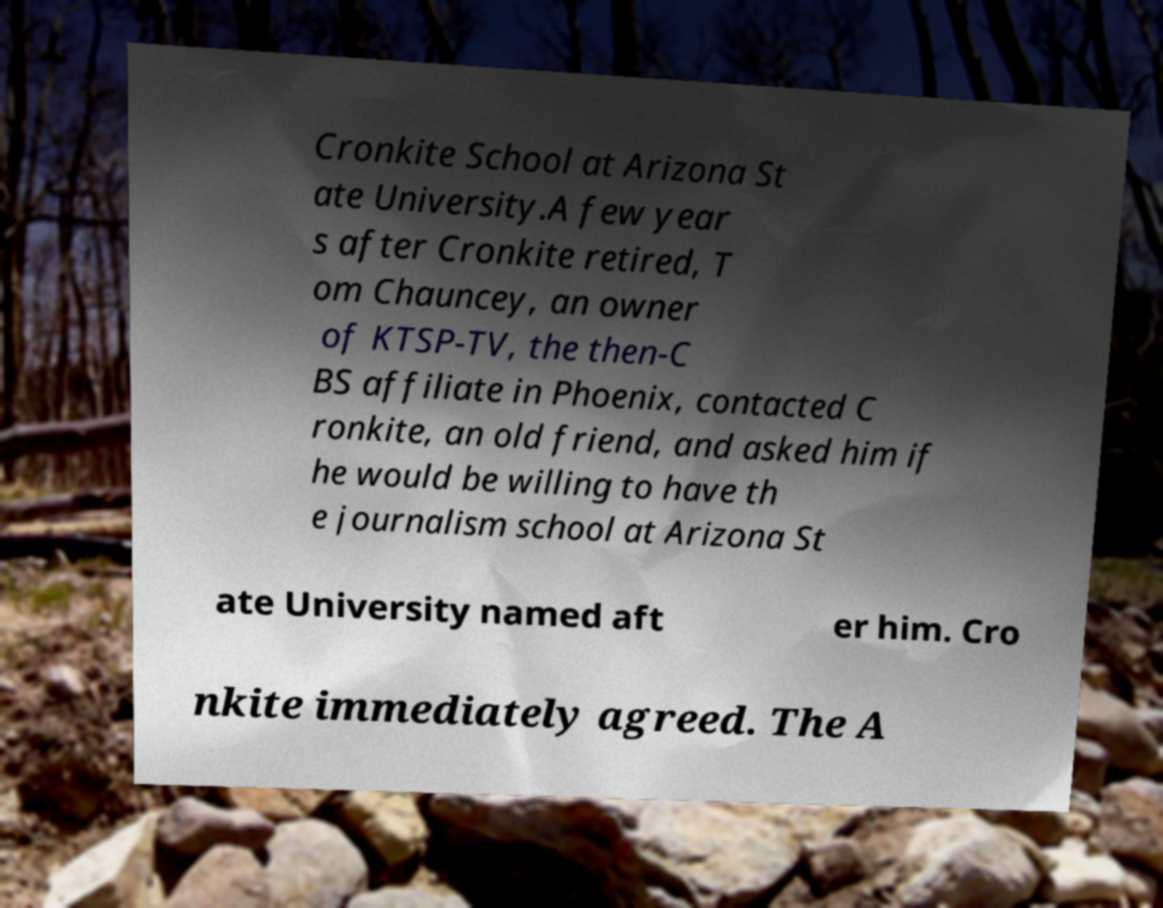Could you extract and type out the text from this image? Cronkite School at Arizona St ate University.A few year s after Cronkite retired, T om Chauncey, an owner of KTSP-TV, the then-C BS affiliate in Phoenix, contacted C ronkite, an old friend, and asked him if he would be willing to have th e journalism school at Arizona St ate University named aft er him. Cro nkite immediately agreed. The A 